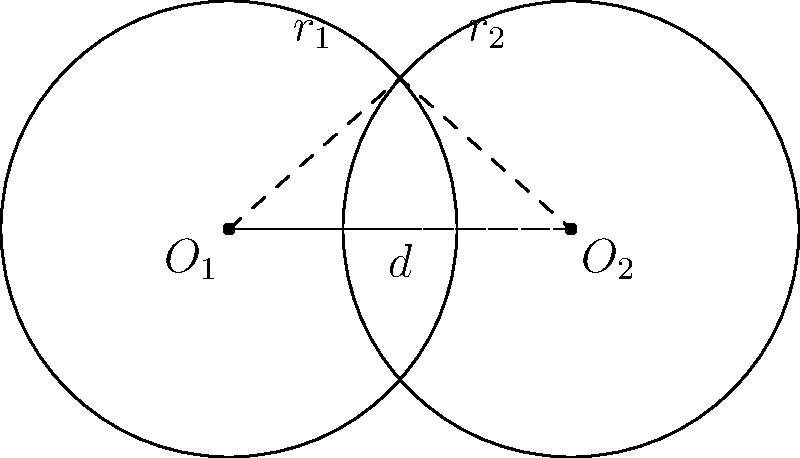During a training session, you notice two circular buoys partially overlapping in the water. Both buoys have a radius of 2 meters, and their centers are 3 meters apart. Calculate the area of the overlapping region between the two buoys. Round your answer to two decimal places. Let's solve this step-by-step:

1) We have two circles with radii $r_1 = r_2 = 2$ meters, and their centers are $d = 3$ meters apart.

2) To find the area of overlap, we need to use the formula for the area of intersection of two circles:

   $A = 2r^2 \arccos(\frac{d}{2r}) - d\sqrt{r^2 - (\frac{d}{2})^2}$

   where $r$ is the radius of both circles and $d$ is the distance between their centers.

3) Let's substitute our values:
   $r = 2$ and $d = 3$

4) Now, let's calculate step by step:

   $A = 2(2^2) \arccos(\frac{3}{2(2)}) - 3\sqrt{2^2 - (\frac{3}{2})^2}$

5) Simplify:
   $A = 8 \arccos(\frac{3}{4}) - 3\sqrt{4 - \frac{9}{4}}$

6) Calculate $\arccos(\frac{3}{4}) \approx 0.7227$ radians

7) Simplify under the square root:
   $A = 8(0.7227) - 3\sqrt{\frac{7}{4}}$

8) Calculate:
   $A \approx 5.7816 - 3(1.3229)$
   $A \approx 5.7816 - 3.9687$
   $A \approx 1.8129$ square meters

9) Rounding to two decimal places:
   $A \approx 1.81$ square meters
Answer: 1.81 m² 